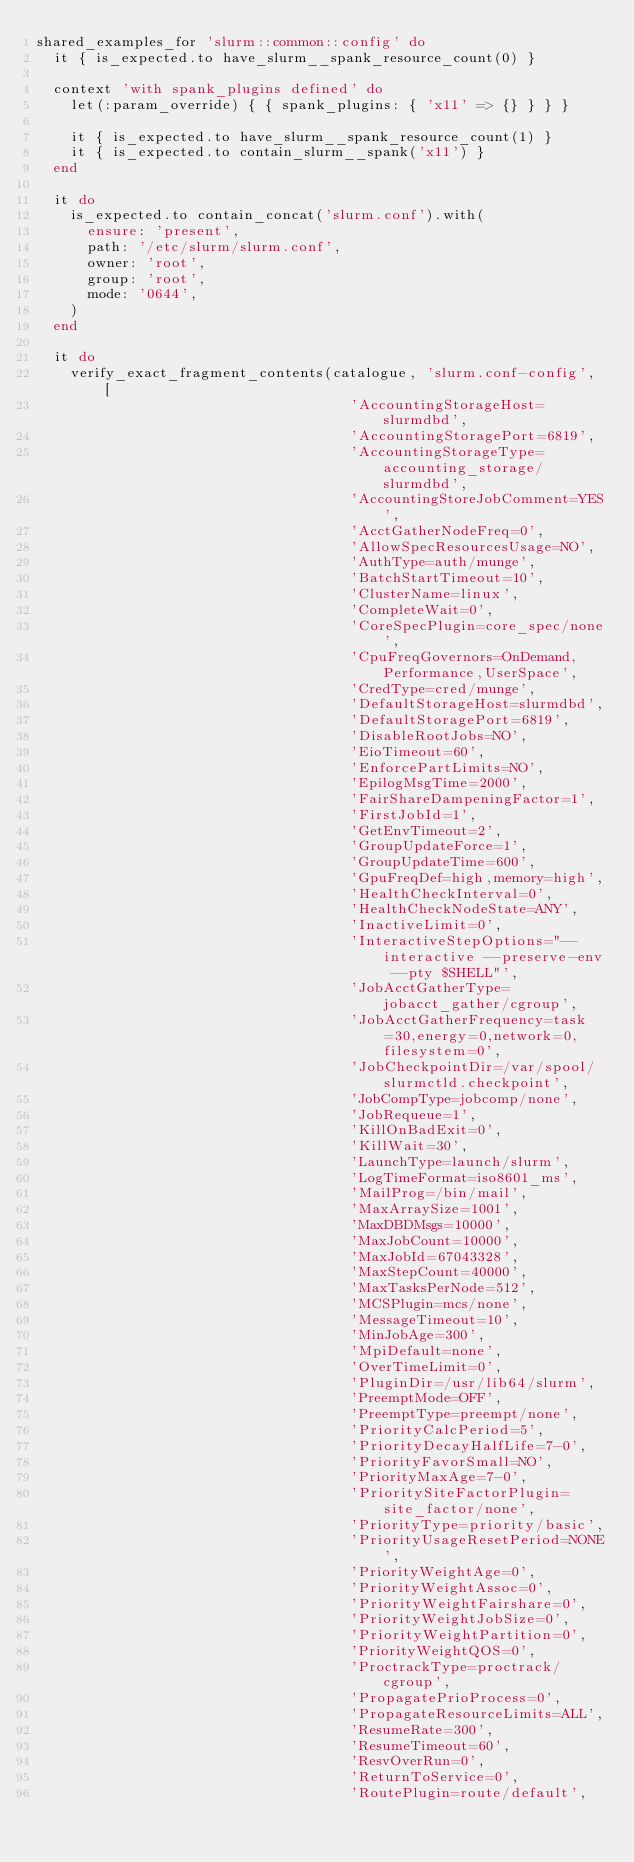Convert code to text. <code><loc_0><loc_0><loc_500><loc_500><_Ruby_>shared_examples_for 'slurm::common::config' do
  it { is_expected.to have_slurm__spank_resource_count(0) }

  context 'with spank_plugins defined' do
    let(:param_override) { { spank_plugins: { 'x11' => {} } } }

    it { is_expected.to have_slurm__spank_resource_count(1) }
    it { is_expected.to contain_slurm__spank('x11') }
  end

  it do
    is_expected.to contain_concat('slurm.conf').with(
      ensure: 'present',
      path: '/etc/slurm/slurm.conf',
      owner: 'root',
      group: 'root',
      mode: '0644',
    )
  end

  it do
    verify_exact_fragment_contents(catalogue, 'slurm.conf-config', [
                                     'AccountingStorageHost=slurmdbd',
                                     'AccountingStoragePort=6819',
                                     'AccountingStorageType=accounting_storage/slurmdbd',
                                     'AccountingStoreJobComment=YES',
                                     'AcctGatherNodeFreq=0',
                                     'AllowSpecResourcesUsage=NO',
                                     'AuthType=auth/munge',
                                     'BatchStartTimeout=10',
                                     'ClusterName=linux',
                                     'CompleteWait=0',
                                     'CoreSpecPlugin=core_spec/none',
                                     'CpuFreqGovernors=OnDemand,Performance,UserSpace',
                                     'CredType=cred/munge',
                                     'DefaultStorageHost=slurmdbd',
                                     'DefaultStoragePort=6819',
                                     'DisableRootJobs=NO',
                                     'EioTimeout=60',
                                     'EnforcePartLimits=NO',
                                     'EpilogMsgTime=2000',
                                     'FairShareDampeningFactor=1',
                                     'FirstJobId=1',
                                     'GetEnvTimeout=2',
                                     'GroupUpdateForce=1',
                                     'GroupUpdateTime=600',
                                     'GpuFreqDef=high,memory=high',
                                     'HealthCheckInterval=0',
                                     'HealthCheckNodeState=ANY',
                                     'InactiveLimit=0',
                                     'InteractiveStepOptions="--interactive --preserve-env --pty $SHELL"',
                                     'JobAcctGatherType=jobacct_gather/cgroup',
                                     'JobAcctGatherFrequency=task=30,energy=0,network=0,filesystem=0',
                                     'JobCheckpointDir=/var/spool/slurmctld.checkpoint',
                                     'JobCompType=jobcomp/none',
                                     'JobRequeue=1',
                                     'KillOnBadExit=0',
                                     'KillWait=30',
                                     'LaunchType=launch/slurm',
                                     'LogTimeFormat=iso8601_ms',
                                     'MailProg=/bin/mail',
                                     'MaxArraySize=1001',
                                     'MaxDBDMsgs=10000',
                                     'MaxJobCount=10000',
                                     'MaxJobId=67043328',
                                     'MaxStepCount=40000',
                                     'MaxTasksPerNode=512',
                                     'MCSPlugin=mcs/none',
                                     'MessageTimeout=10',
                                     'MinJobAge=300',
                                     'MpiDefault=none',
                                     'OverTimeLimit=0',
                                     'PluginDir=/usr/lib64/slurm',
                                     'PreemptMode=OFF',
                                     'PreemptType=preempt/none',
                                     'PriorityCalcPeriod=5',
                                     'PriorityDecayHalfLife=7-0',
                                     'PriorityFavorSmall=NO',
                                     'PriorityMaxAge=7-0',
                                     'PrioritySiteFactorPlugin=site_factor/none',
                                     'PriorityType=priority/basic',
                                     'PriorityUsageResetPeriod=NONE',
                                     'PriorityWeightAge=0',
                                     'PriorityWeightAssoc=0',
                                     'PriorityWeightFairshare=0',
                                     'PriorityWeightJobSize=0',
                                     'PriorityWeightPartition=0',
                                     'PriorityWeightQOS=0',
                                     'ProctrackType=proctrack/cgroup',
                                     'PropagatePrioProcess=0',
                                     'PropagateResourceLimits=ALL',
                                     'ResumeRate=300',
                                     'ResumeTimeout=60',
                                     'ResvOverRun=0',
                                     'ReturnToService=0',
                                     'RoutePlugin=route/default',</code> 